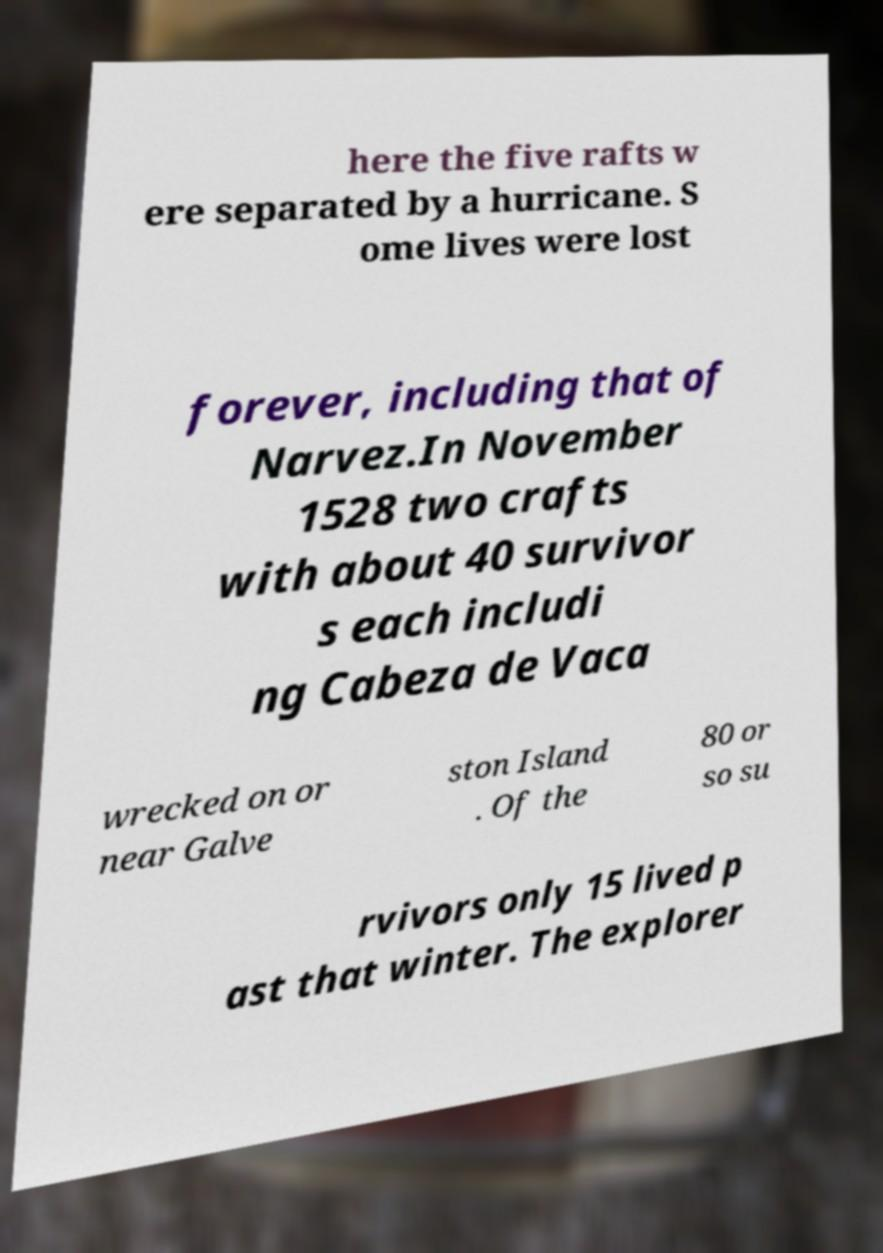Could you assist in decoding the text presented in this image and type it out clearly? here the five rafts w ere separated by a hurricane. S ome lives were lost forever, including that of Narvez.In November 1528 two crafts with about 40 survivor s each includi ng Cabeza de Vaca wrecked on or near Galve ston Island . Of the 80 or so su rvivors only 15 lived p ast that winter. The explorer 